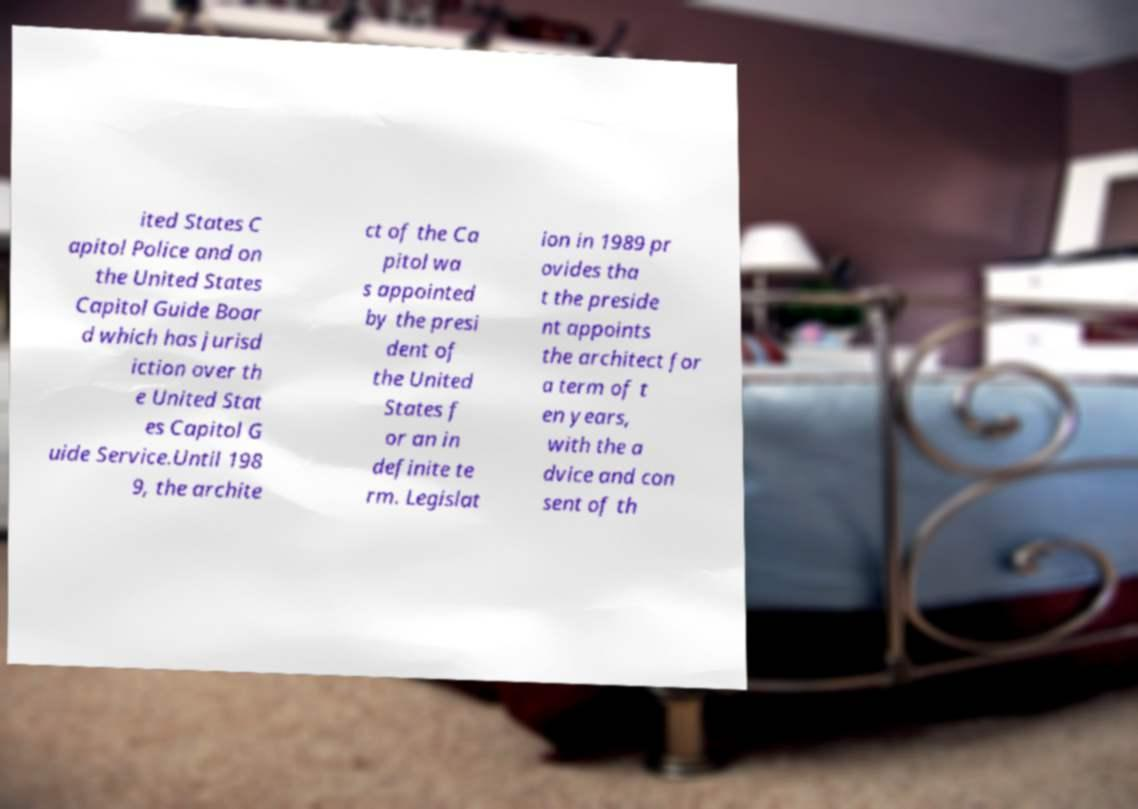I need the written content from this picture converted into text. Can you do that? ited States C apitol Police and on the United States Capitol Guide Boar d which has jurisd iction over th e United Stat es Capitol G uide Service.Until 198 9, the archite ct of the Ca pitol wa s appointed by the presi dent of the United States f or an in definite te rm. Legislat ion in 1989 pr ovides tha t the preside nt appoints the architect for a term of t en years, with the a dvice and con sent of th 